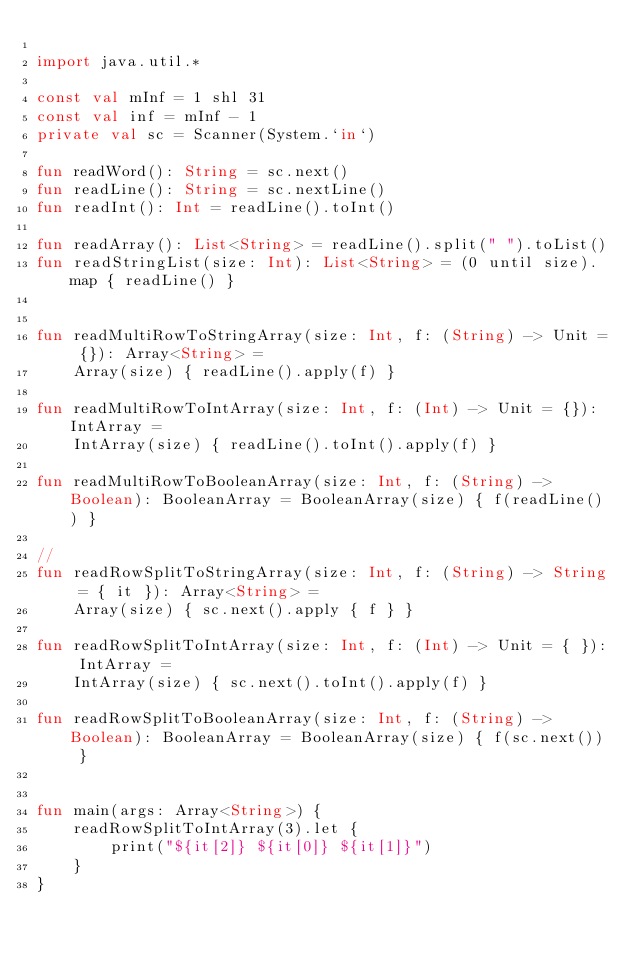<code> <loc_0><loc_0><loc_500><loc_500><_Kotlin_>
import java.util.*

const val mInf = 1 shl 31
const val inf = mInf - 1
private val sc = Scanner(System.`in`)

fun readWord(): String = sc.next()
fun readLine(): String = sc.nextLine()
fun readInt(): Int = readLine().toInt()

fun readArray(): List<String> = readLine().split(" ").toList()
fun readStringList(size: Int): List<String> = (0 until size).map { readLine() }


fun readMultiRowToStringArray(size: Int, f: (String) -> Unit = {}): Array<String> =
    Array(size) { readLine().apply(f) }

fun readMultiRowToIntArray(size: Int, f: (Int) -> Unit = {}): IntArray =
    IntArray(size) { readLine().toInt().apply(f) }

fun readMultiRowToBooleanArray(size: Int, f: (String) -> Boolean): BooleanArray = BooleanArray(size) { f(readLine()) }

//
fun readRowSplitToStringArray(size: Int, f: (String) -> String = { it }): Array<String> =
    Array(size) { sc.next().apply { f } }

fun readRowSplitToIntArray(size: Int, f: (Int) -> Unit = { }): IntArray =
    IntArray(size) { sc.next().toInt().apply(f) }

fun readRowSplitToBooleanArray(size: Int, f: (String) -> Boolean): BooleanArray = BooleanArray(size) { f(sc.next()) }


fun main(args: Array<String>) {
    readRowSplitToIntArray(3).let {
        print("${it[2]} ${it[0]} ${it[1]}")
    }
}</code> 